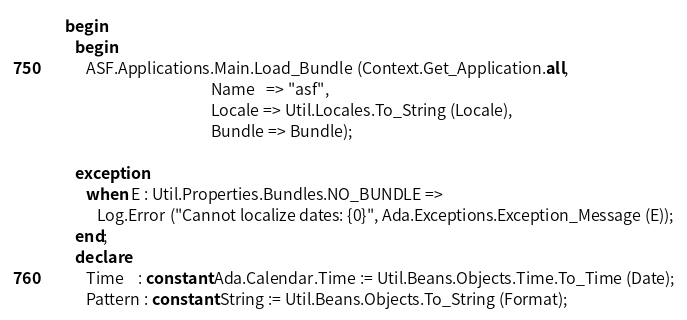<code> <loc_0><loc_0><loc_500><loc_500><_Ada_>   begin
      begin
         ASF.Applications.Main.Load_Bundle (Context.Get_Application.all,
                                            Name   => "asf",
                                            Locale => Util.Locales.To_String (Locale),
                                            Bundle => Bundle);

      exception
         when E : Util.Properties.Bundles.NO_BUNDLE =>
            Log.Error ("Cannot localize dates: {0}", Ada.Exceptions.Exception_Message (E));
      end;
      declare
         Time    : constant Ada.Calendar.Time := Util.Beans.Objects.Time.To_Time (Date);
         Pattern : constant String := Util.Beans.Objects.To_String (Format);</code> 